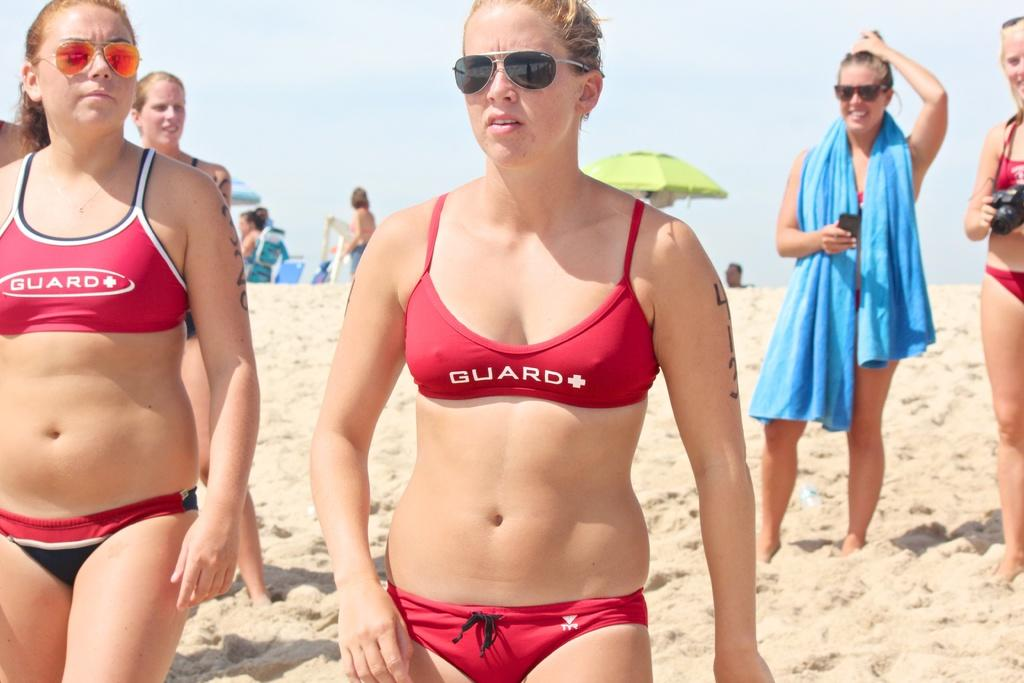<image>
Describe the image concisely. Two women part of the life guard team standing on beach wearing red swimsuits 